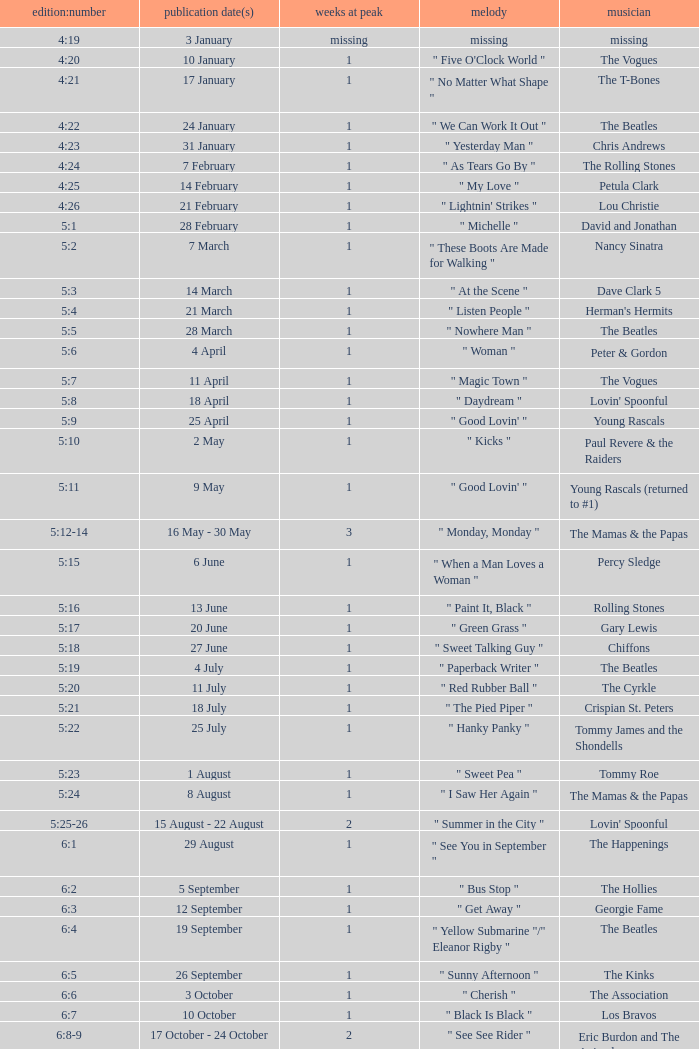An artist of the Beatles with an issue date(s) of 19 September has what as the listed weeks on top? 1.0. 